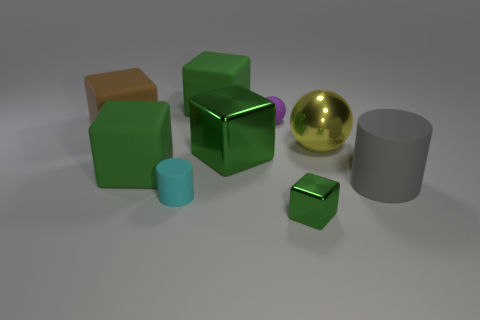Subtract all gray cylinders. How many green blocks are left? 4 Subtract all brown cubes. How many cubes are left? 4 Subtract all small blocks. How many blocks are left? 4 Subtract 1 blocks. How many blocks are left? 4 Add 1 large green matte spheres. How many objects exist? 10 Subtract all cyan blocks. Subtract all blue spheres. How many blocks are left? 5 Subtract all cylinders. How many objects are left? 7 Add 2 brown rubber cubes. How many brown rubber cubes are left? 3 Add 5 gray matte cylinders. How many gray matte cylinders exist? 6 Subtract 0 cyan blocks. How many objects are left? 9 